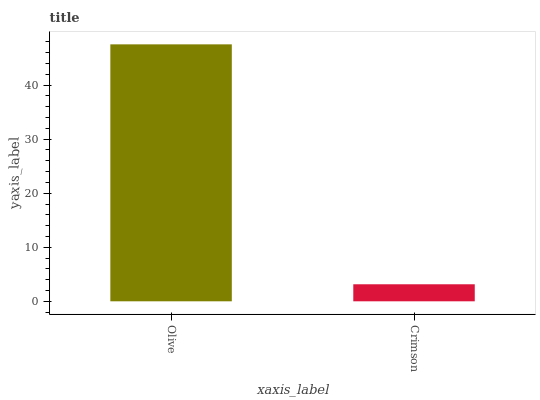Is Crimson the maximum?
Answer yes or no. No. Is Olive greater than Crimson?
Answer yes or no. Yes. Is Crimson less than Olive?
Answer yes or no. Yes. Is Crimson greater than Olive?
Answer yes or no. No. Is Olive less than Crimson?
Answer yes or no. No. Is Olive the high median?
Answer yes or no. Yes. Is Crimson the low median?
Answer yes or no. Yes. Is Crimson the high median?
Answer yes or no. No. Is Olive the low median?
Answer yes or no. No. 